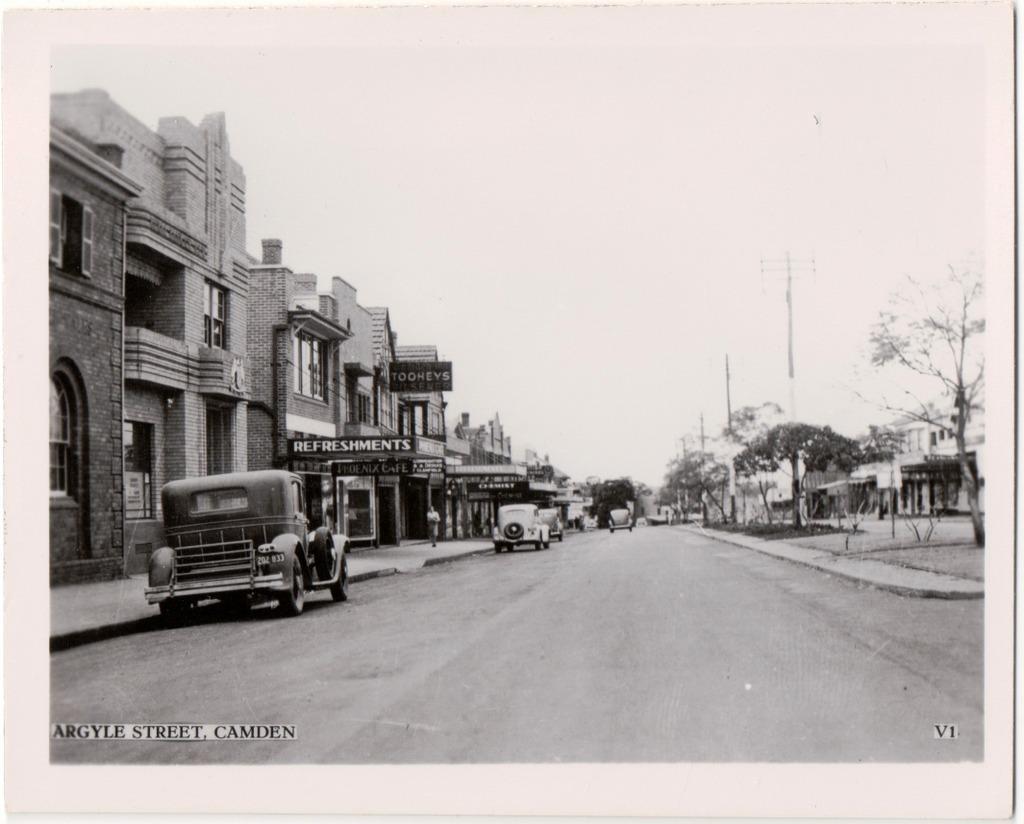Can you describe this image briefly? In this image there are vehicles on the road. On the left side there are buildings, boards with some text written on it. On the right side there are trees, poles and buildings. In the background there are trees and there are vehicles and the sky is cloudy. 